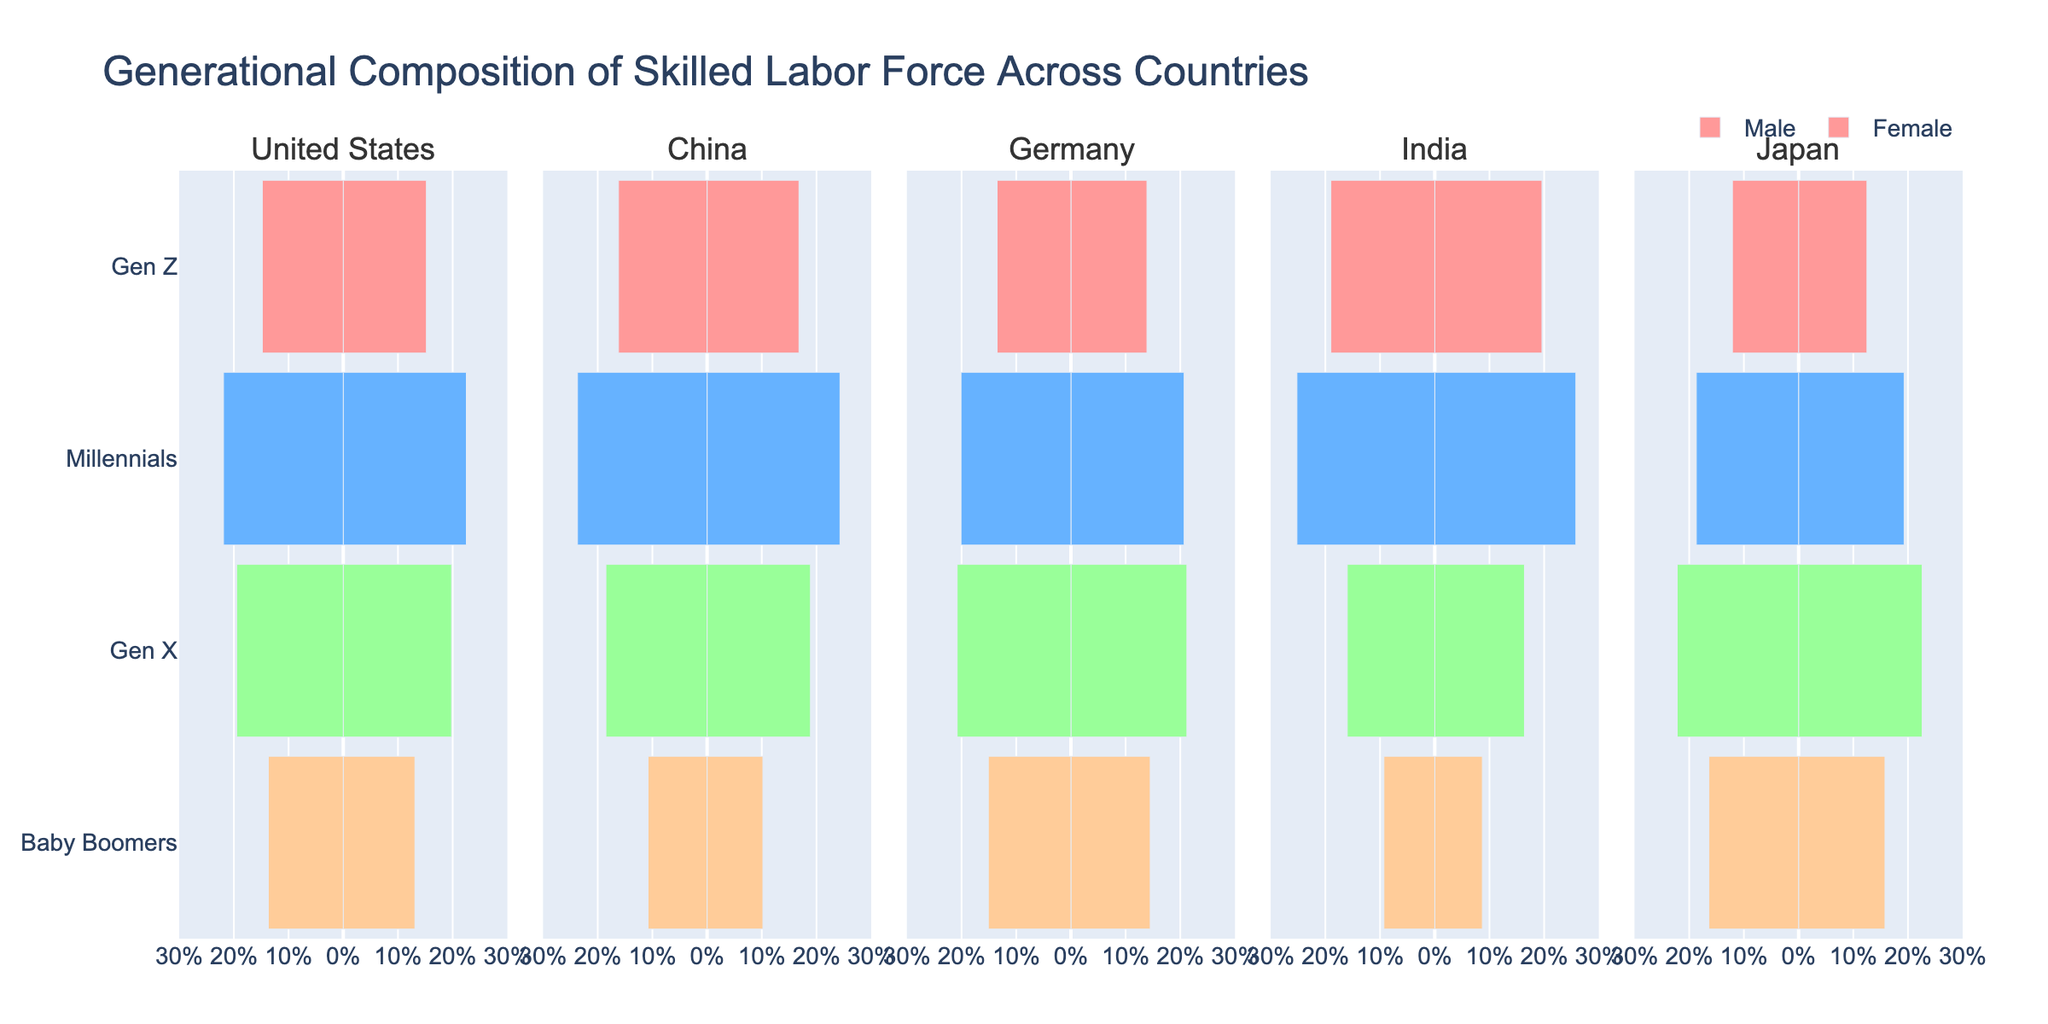What generation has the highest composition of the skilled labor force in Germany? To answer this, look at the bars representing Germany and compare the lengths of the bars for each generation. The 'Gen X' bars for both males and females are the longest in Germany.
Answer: Gen X Which country has the highest percentage of Millennials in the skilled labor force? Examine the 'Millennials' bars across all countries. The longest 'Millennials' bars for both males and females are in India.
Answer: India Are there more male Baby Boomers in the United States or Japan? Compare the length of the bars representing male Baby Boomers in both the United States and Japan.
Answer: Japan Which generation has the smallest proportion of the skilled labor force in India? Look at the bars for India and identify the generation with the shortest bars. The shortest bars correspond to the 'Baby Boomers'.
Answer: Baby Boomers By how much does the percentage of male Millennials in China exceed that of male Millennials in Japan? Find the 'Male' bar for 'Millennials' in both China and Japan. The bar in China is at 24.3%, and in Japan, it is at 19.3%. Subtract these two values: 24.3% - 19.3% = 5.0%.
Answer: 5.0% How does the percentage of female Gen Z in Germany compare with that in the United States? Look at the 'Female' bars for 'Gen Z' in both Germany and the United States. The bar in Germany is at 13.5%, and in the United States, it is at 14.8%. Compare these values to see which is higher or lower.
Answer: The United States is higher What is the average percentage of skilled labor attributed to Gen X across all countries? Add up the Gen X percentages for both males and females across all countries: (19.8 + 19.5) + (18.9 + 18.5) + (21.2 + 20.8) + (16.4 + 16.0) + (22.6 + 22.2) = 196.2. There are 10 values, so the average is 196.2 / 10 = 19.62%.
Answer: 19.62% Is the percentage of male Gen Z workers higher in China or India? Compare the 'Male' bar for 'Gen Z' in China and India. The bar in China is at 16.8%, and in India, it is at 19.6%.
Answer: India What is the total percentage of female Baby Boomers in the skilled labor force across all countries? Sum up the values for female Baby Boomers from all countries: 13.7+10.8+15.1+9.3+16.4 = 65.3%.
Answer: 65.3% Which gender has a higher composition for Millennials in Germany? Compare the 'Male' and 'Female' bars for 'Millennials' in Germany. Males are at 20.7%, and females are at 20.1%.
Answer: Male 